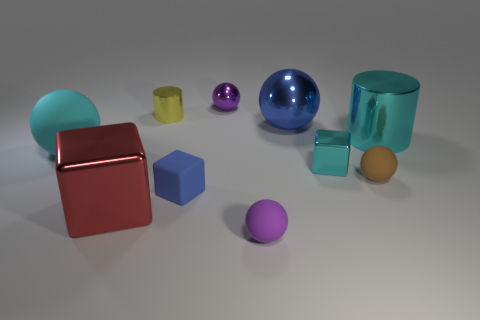What is the color of the tiny metal cube?
Make the answer very short. Cyan. What color is the metallic sphere that is the same size as the brown thing?
Your answer should be compact. Purple. Is the shape of the tiny purple object that is in front of the small yellow metallic cylinder the same as  the red thing?
Keep it short and to the point. No. There is a large ball that is on the right side of the cyan object left of the metallic block right of the tiny purple metal sphere; what is its color?
Make the answer very short. Blue. Are there any blue matte objects?
Offer a terse response. Yes. How many other objects are the same size as the red metal cube?
Your answer should be very brief. 3. There is a large cylinder; is it the same color as the big sphere in front of the big cyan cylinder?
Your answer should be very brief. Yes. What number of things are either small purple matte balls or large purple cubes?
Give a very brief answer. 1. Is there any other thing that has the same color as the tiny shiny cylinder?
Ensure brevity in your answer.  No. Is the material of the blue cube the same as the object that is in front of the red metal block?
Make the answer very short. Yes. 